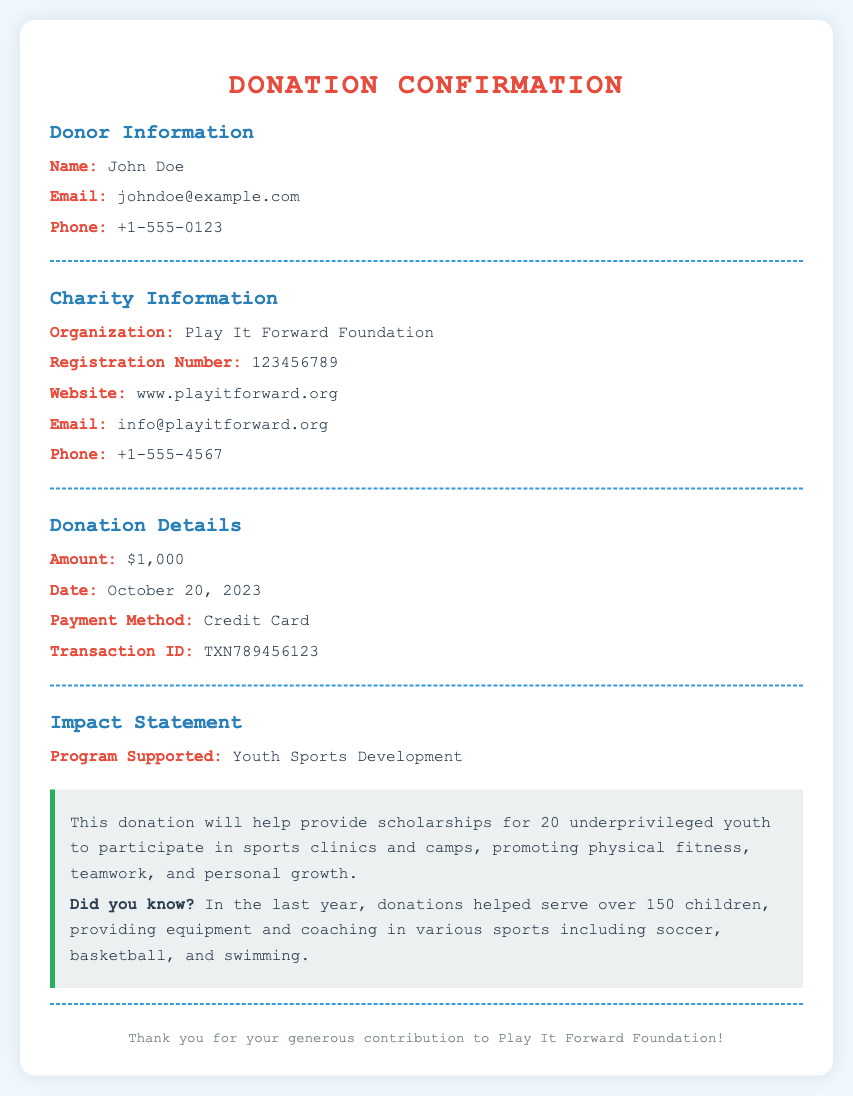What is the name of the donor? The document explicitly states the name of the donor in the donor information section.
Answer: John Doe What is the donation amount? The donation amount is mentioned clearly in the donation details section of the document.
Answer: $1,000 On what date was the donation made? The date of the donation is recorded in the donation details section.
Answer: October 20, 2023 What organization received the donation? The document specifies the organization that received the donation in the charity information section.
Answer: Play It Forward Foundation How many youth will benefit from the donation? The impact statement elaborates on how many youths will receive scholarships supported by the donation.
Answer: 20 What program is supported by this donation? The specific program that this donation supports is highlighted in the impact statement.
Answer: Youth Sports Development What is the registration number of the charity? The registration number of the Play It Forward Foundation is included in the charity information section of the document.
Answer: 123456789 What method was used for the payment? The method of payment is clearly listed in the donation details section.
Answer: Credit Card What will the donation help provide? The impact statement explains what the donation will help facilitate for underprivileged youth.
Answer: Scholarships for sports clinics and camps 